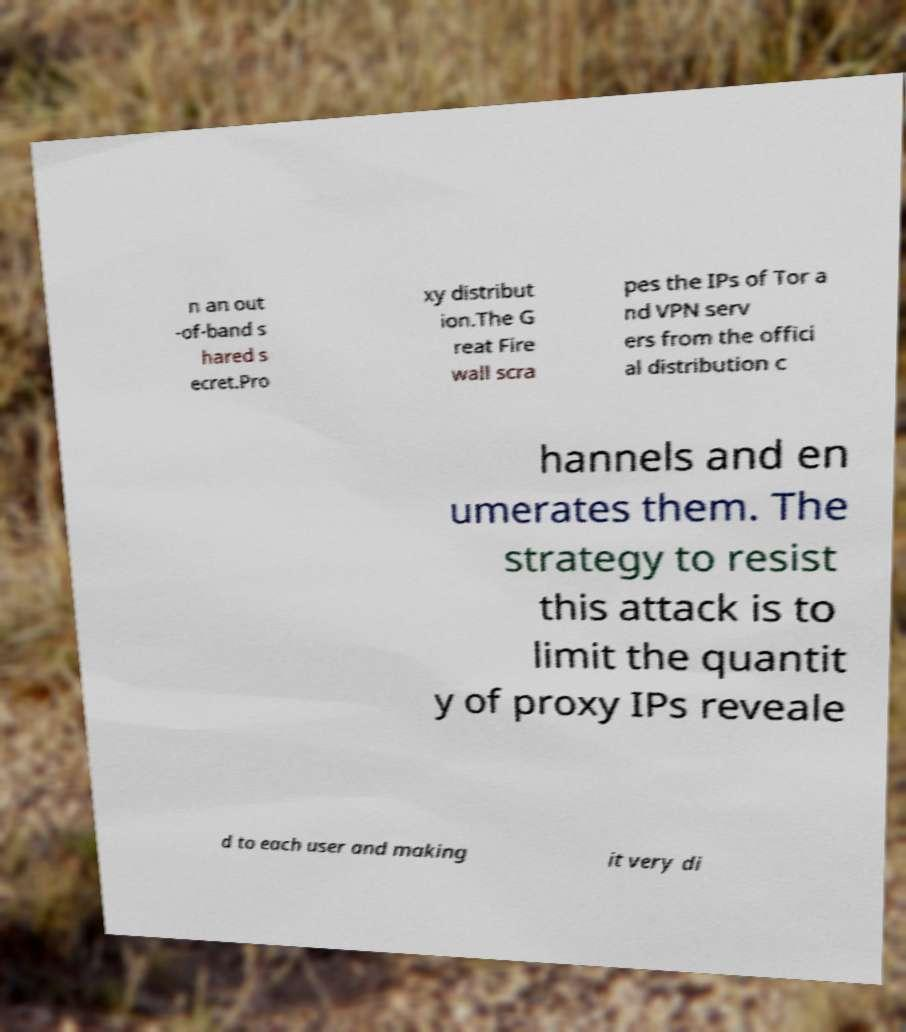Could you assist in decoding the text presented in this image and type it out clearly? n an out -of-band s hared s ecret.Pro xy distribut ion.The G reat Fire wall scra pes the IPs of Tor a nd VPN serv ers from the offici al distribution c hannels and en umerates them. The strategy to resist this attack is to limit the quantit y of proxy IPs reveale d to each user and making it very di 